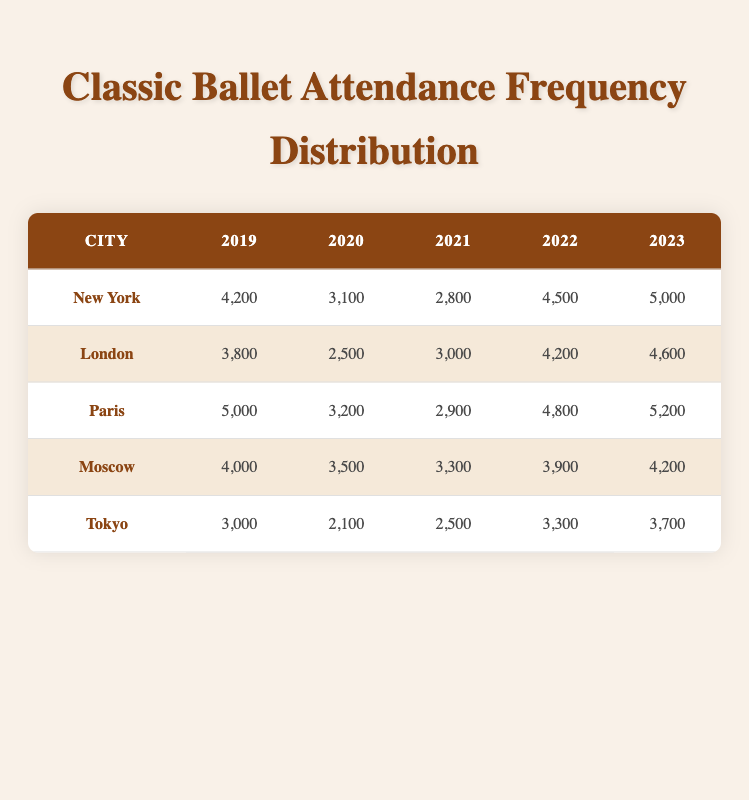What city had the highest attendance in 2023? By looking at the 2023 column for each city, I can see that Paris had the highest attendance with 5,200 performances attended.
Answer: Paris Which city saw a decline in attendance from 2019 to 2021? To find this, I compare the 2019 and 2021 attendance values for each city. New York (4,200 to 2,800), London (3,800 to 3,000), Paris (5,000 to 2,900), Moscow (4,000 to 3,300), and Tokyo (3,000 to 2,500) all experienced a decline, but Paris had the largest decline of 2,100 performances.
Answer: Paris What was the average attendance for Moscow over the five years? The attendance figures for Moscow are 4,000, 3,500, 3,300, 3,900, and 4,200. I sum these values to get 18,900 and divide by 5. Thus, the average is 18,900 / 5 = 3,780.
Answer: 3,780 True or False: London had a higher number of performances attended in 2021 than Tokyo. Checking both cities in the table for 2021, London had 3,000 while Tokyo had 2,500. Since 3,000 is greater than 2,500, this statement is True.
Answer: True Which city's attendance showed the most significant increase from 2020 to 2023? I compare the attendance from 2020 to 2023 for each city: New York (3,100 to 5,000 = +1,900), London (2,500 to 4,600 = +2,100), Paris (3,200 to 5,200 = +2,000), Moscow (3,500 to 4,200 = +700), and Tokyo (2,100 to 3,700 = +1,600). London had the greatest increase of 2,100 performances.
Answer: London What was the total attendance for classic ballet performances in New York over the five-year period? I sum the attendance figures for New York: 4,200 + 3,100 + 2,800 + 4,500 + 5,000 = 19,600. Therefore, the total attendance for New York is 19,600.
Answer: 19,600 